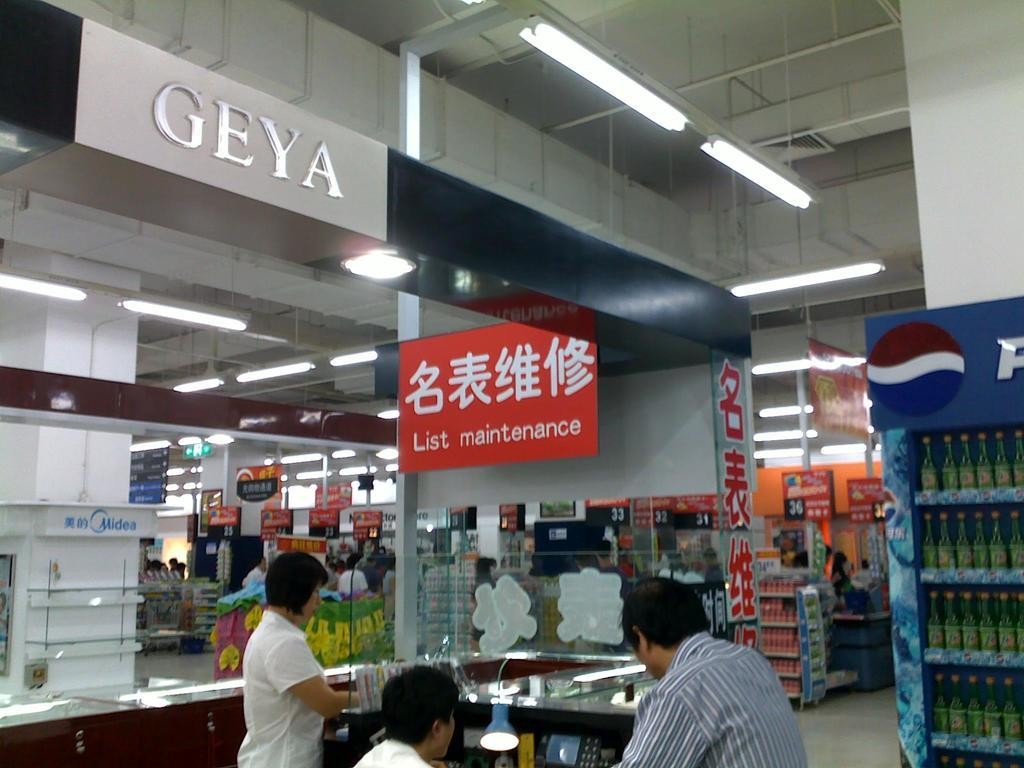<image>
Share a concise interpretation of the image provided. A red sign reading List Maintenance hangs where people are standing. 